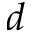Convert formula to latex. <formula><loc_0><loc_0><loc_500><loc_500>d</formula> 